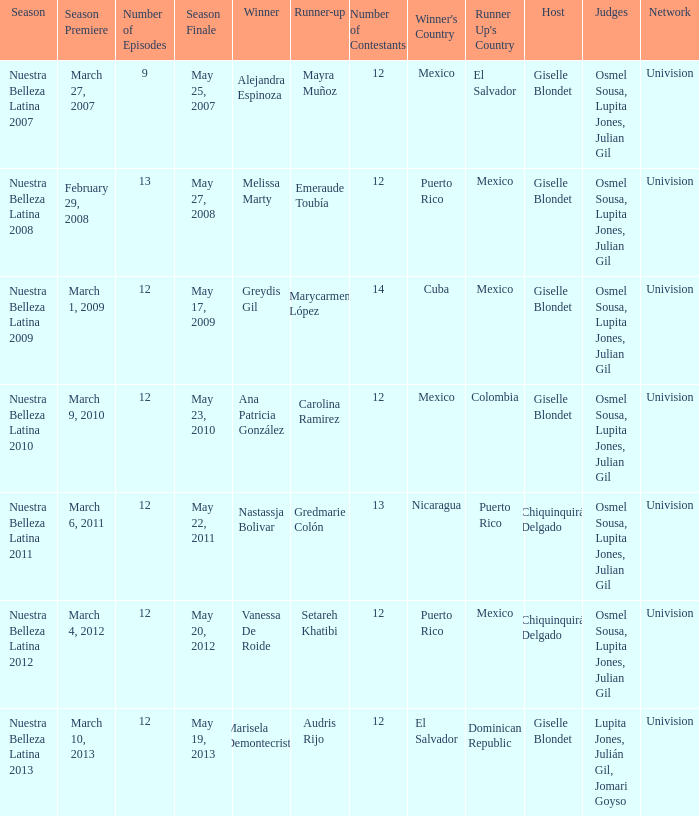What season had mexico as the runner up with melissa marty winning? Nuestra Belleza Latina 2008. 